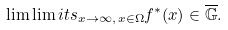<formula> <loc_0><loc_0><loc_500><loc_500>\lim \lim i t s _ { x \to \infty , \, x \in \Omega } f ^ { * } ( x ) \in \overline { \mathbb { G } } .</formula> 